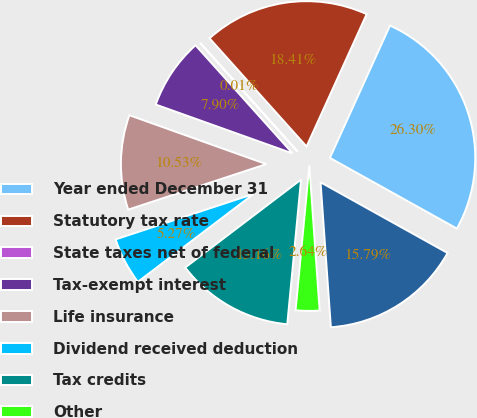Convert chart to OTSL. <chart><loc_0><loc_0><loc_500><loc_500><pie_chart><fcel>Year ended December 31<fcel>Statutory tax rate<fcel>State taxes net of federal<fcel>Tax-exempt interest<fcel>Life insurance<fcel>Dividend received deduction<fcel>Tax credits<fcel>Other<fcel>Effective tax rate<nl><fcel>26.31%<fcel>18.42%<fcel>0.01%<fcel>7.9%<fcel>10.53%<fcel>5.27%<fcel>13.16%<fcel>2.64%<fcel>15.79%<nl></chart> 